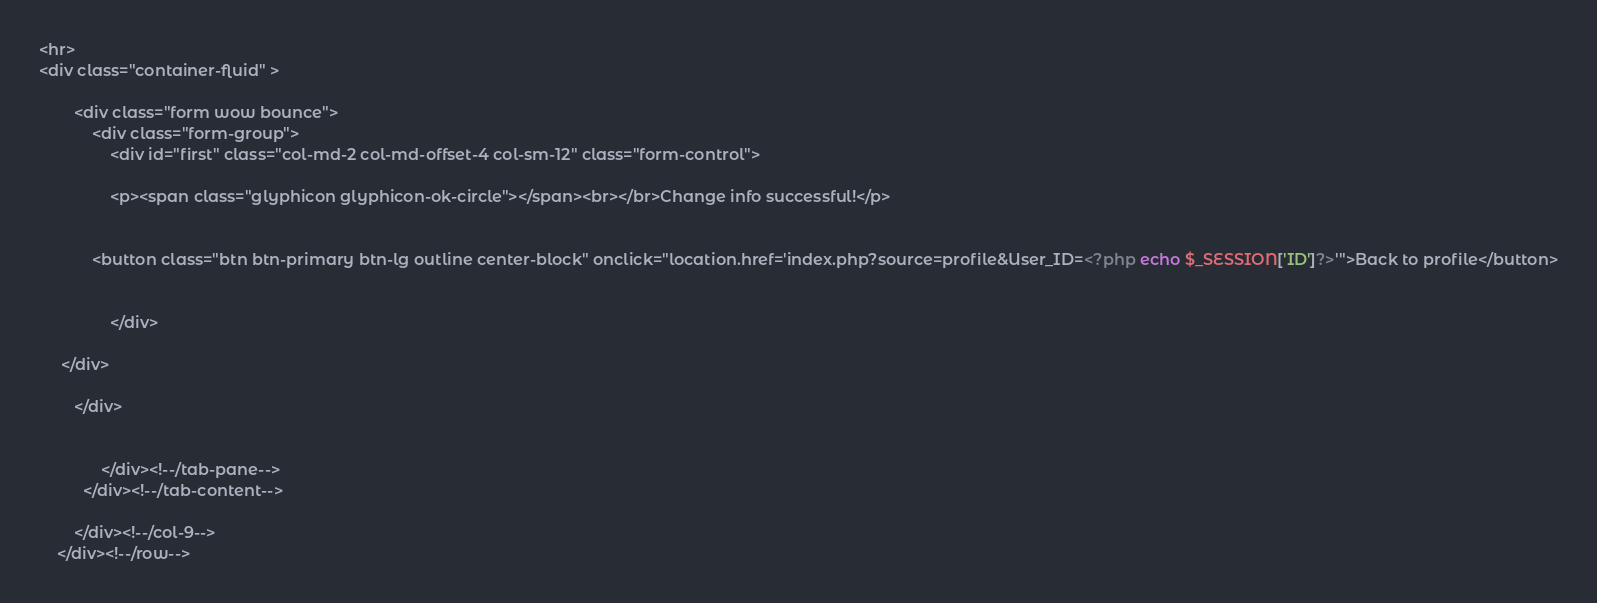Convert code to text. <code><loc_0><loc_0><loc_500><loc_500><_PHP_><hr>
<div class="container-fluid" >
    
    	<div class="form wow bounce">
    		<div class="form-group">	
      			<div id="first" class="col-md-2 col-md-offset-4 col-sm-12" class="form-control">
      				
      			<p><span class="glyphicon glyphicon-ok-circle"></span><br></br>Change info successful!</p> 
      			

            <button class="btn btn-primary btn-lg outline center-block" onclick="location.href='index.php?source=profile&User_ID=<?php echo $_SESSION['ID']?>'">Back to profile</button>


      			</div>

     </div>
        		
        </div>
    
               
              </div><!--/tab-pane-->
          </div><!--/tab-content-->

        </div><!--/col-9-->
    </div><!--/row-->
</code> 